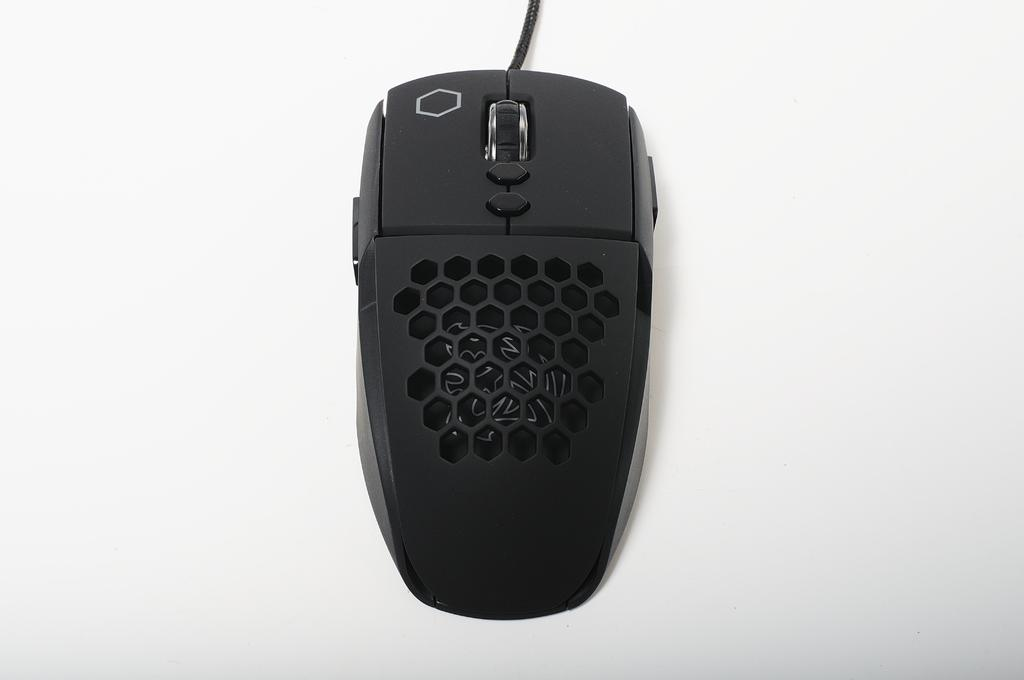What type of animal is present in the image? There is a mouse in the image. What is the color of the mouse? The mouse is black in color. How many ears does the cow have in the image? There is no cow present in the image, so it is not possible to determine the number of ears it might have. 